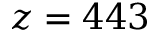<formula> <loc_0><loc_0><loc_500><loc_500>z = 4 4 3</formula> 